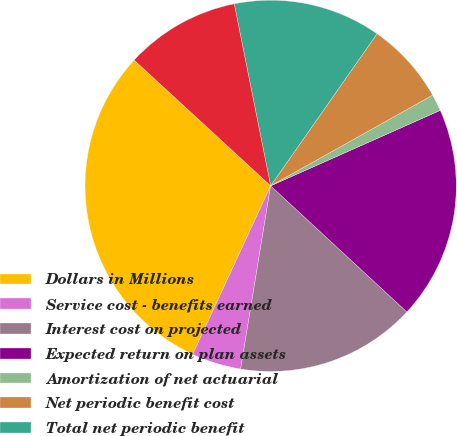Convert chart to OTSL. <chart><loc_0><loc_0><loc_500><loc_500><pie_chart><fcel>Dollars in Millions<fcel>Service cost - benefits earned<fcel>Interest cost on projected<fcel>Expected return on plan assets<fcel>Amortization of net actuarial<fcel>Net periodic benefit cost<fcel>Total net periodic benefit<fcel>Continuing operations<nl><fcel>29.95%<fcel>4.31%<fcel>15.7%<fcel>18.55%<fcel>1.46%<fcel>7.16%<fcel>12.86%<fcel>10.01%<nl></chart> 